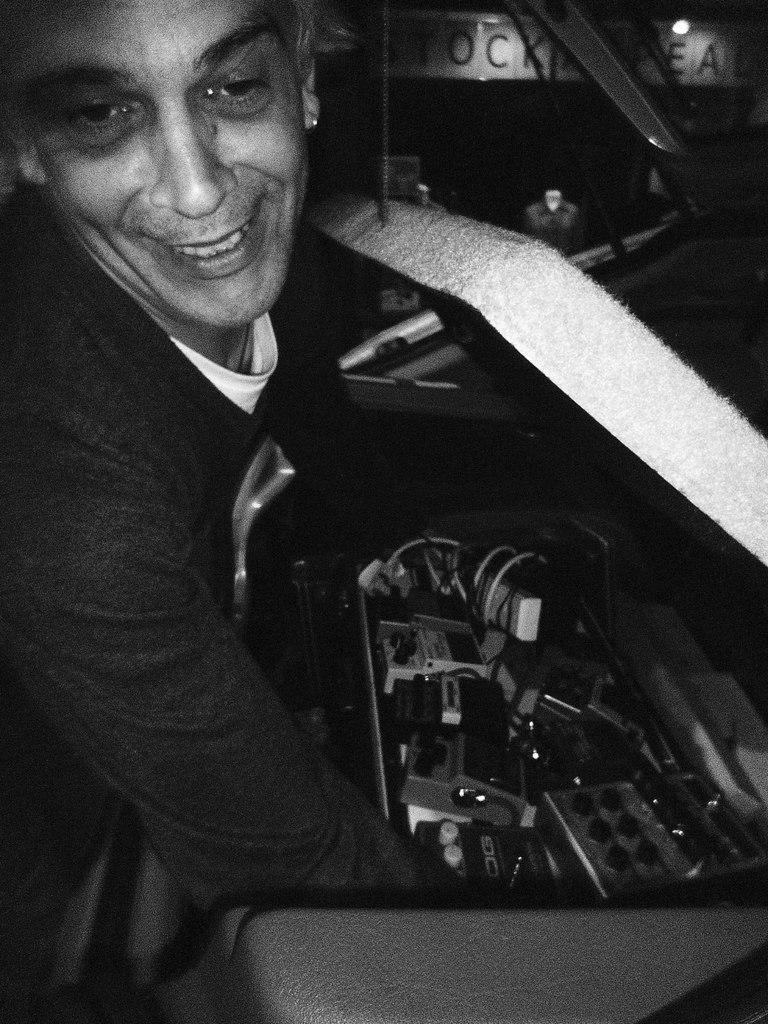What is the main subject of the image? The main subject of the image is a man. What is the man doing in the image? The man appears to be repairing a car. Where is the maid in the image? There is no maid present in the image. What type of hole can be seen in the image? There is no hole present in the image. What is the man gripping in the image? The provided facts do not mention the man gripping anything specific. 